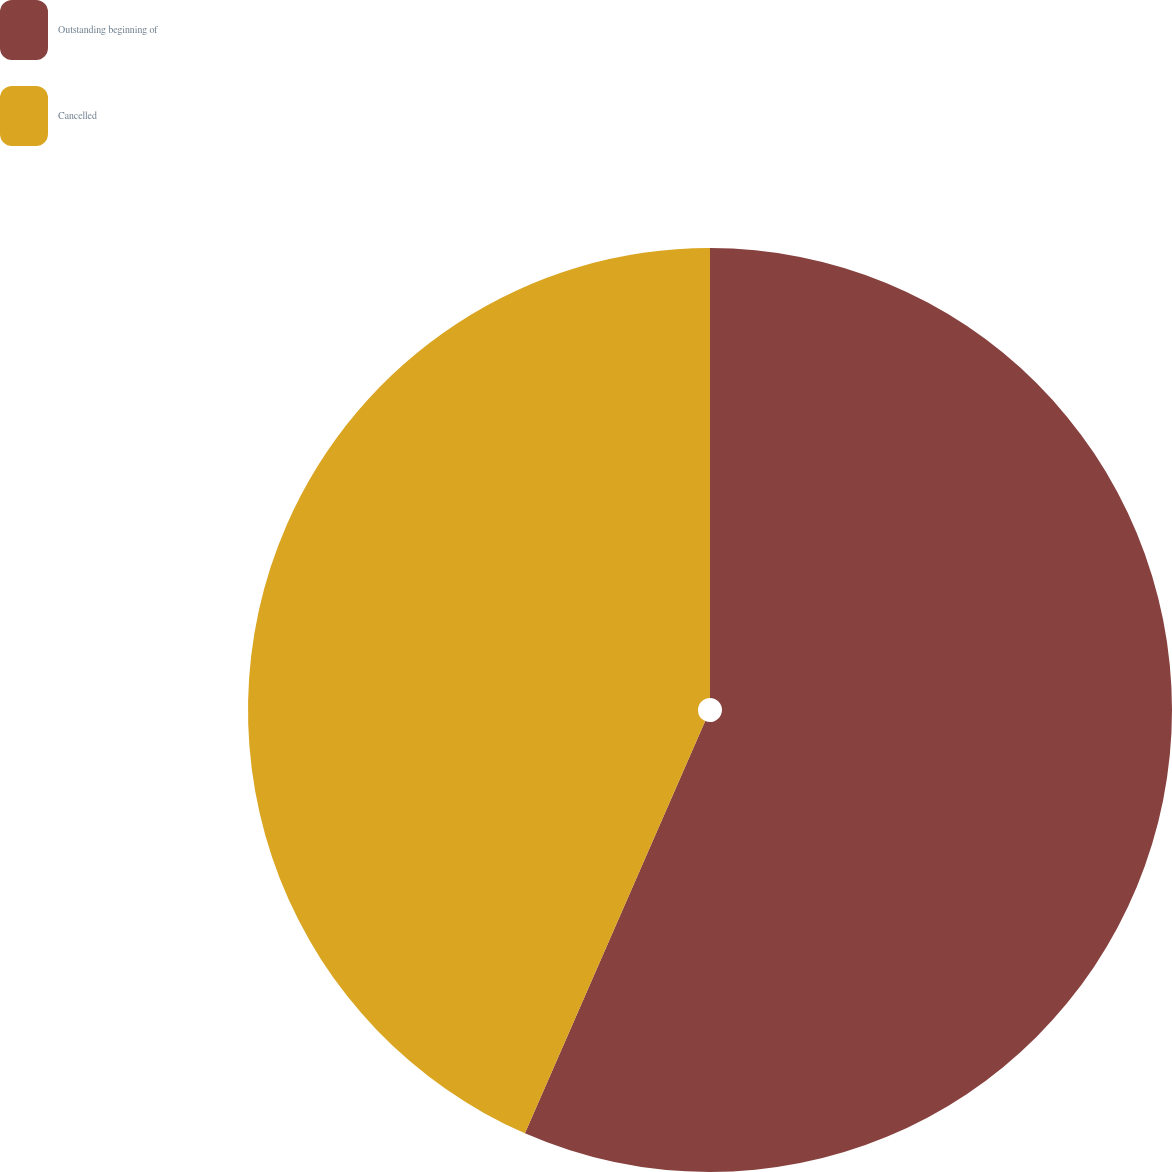Convert chart. <chart><loc_0><loc_0><loc_500><loc_500><pie_chart><fcel>Outstanding beginning of<fcel>Cancelled<nl><fcel>56.56%<fcel>43.44%<nl></chart> 